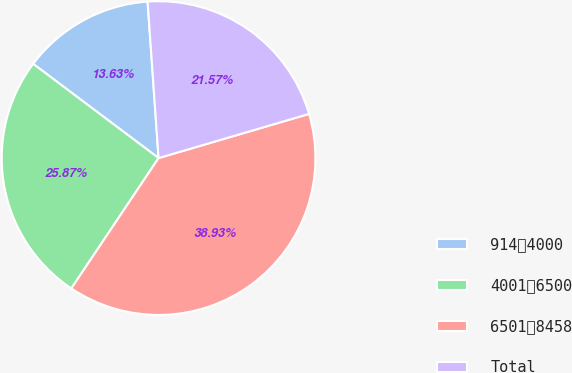<chart> <loc_0><loc_0><loc_500><loc_500><pie_chart><fcel>9144000<fcel>40016500<fcel>65018458<fcel>Total<nl><fcel>13.63%<fcel>25.87%<fcel>38.93%<fcel>21.57%<nl></chart> 